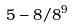Convert formula to latex. <formula><loc_0><loc_0><loc_500><loc_500>5 - 8 / 8 ^ { 9 }</formula> 